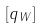<formula> <loc_0><loc_0><loc_500><loc_500>[ q _ { W } ]</formula> 